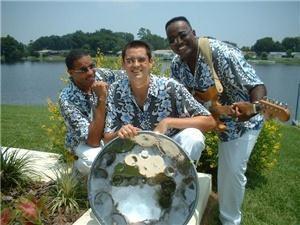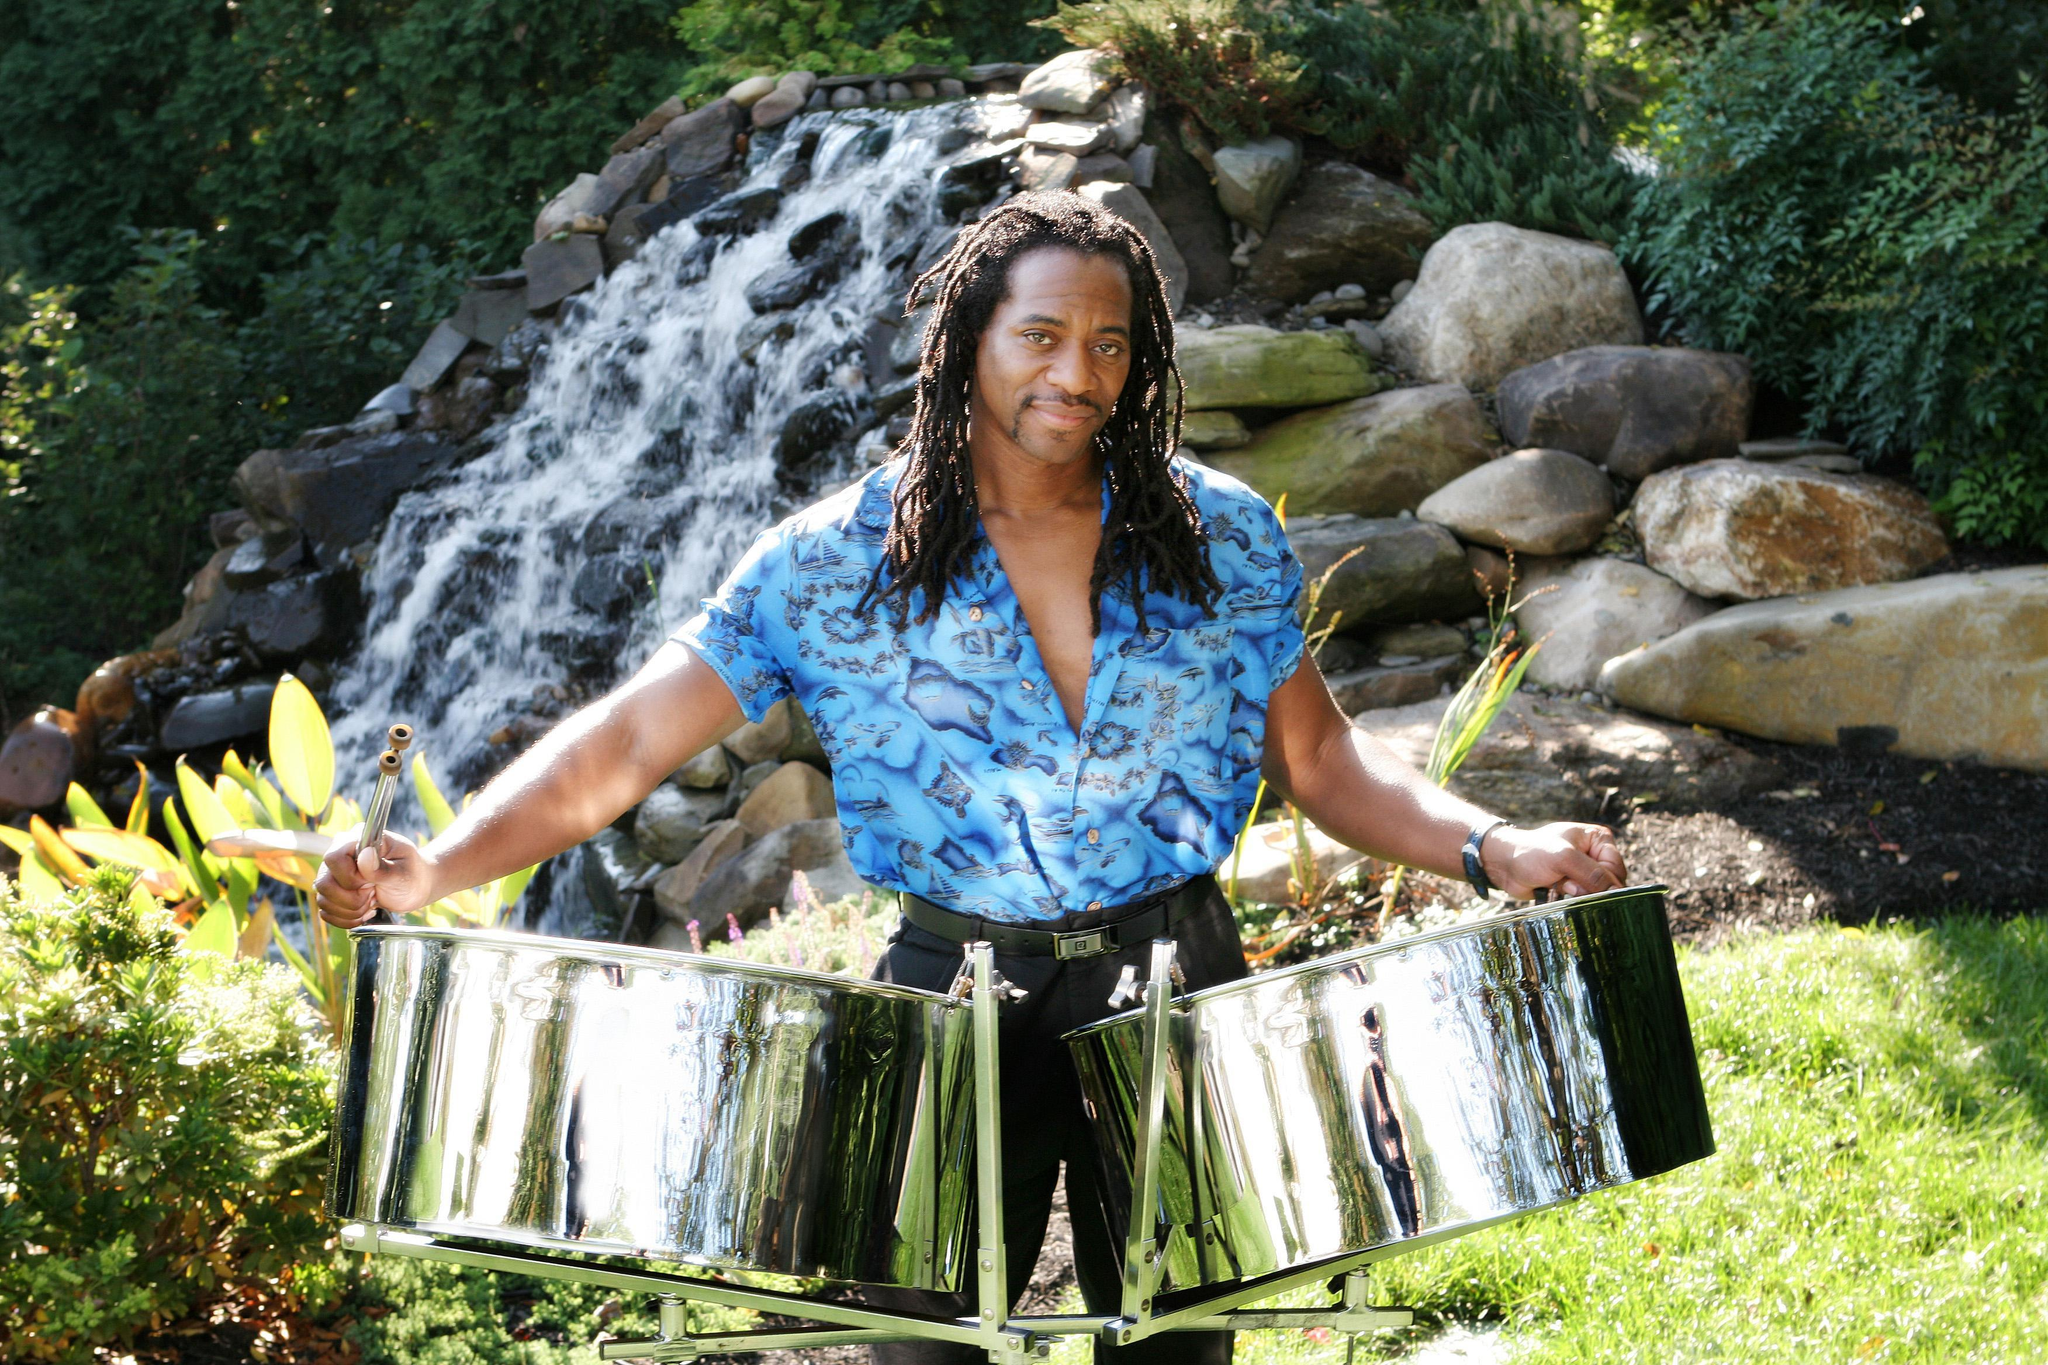The first image is the image on the left, the second image is the image on the right. Evaluate the accuracy of this statement regarding the images: "People are playing bongo drums.". Is it true? Answer yes or no. No. 